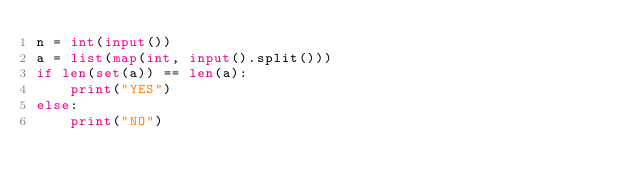<code> <loc_0><loc_0><loc_500><loc_500><_Python_>n = int(input())
a = list(map(int, input().split()))
if len(set(a)) == len(a):
    print("YES")
else:
    print("NO")</code> 